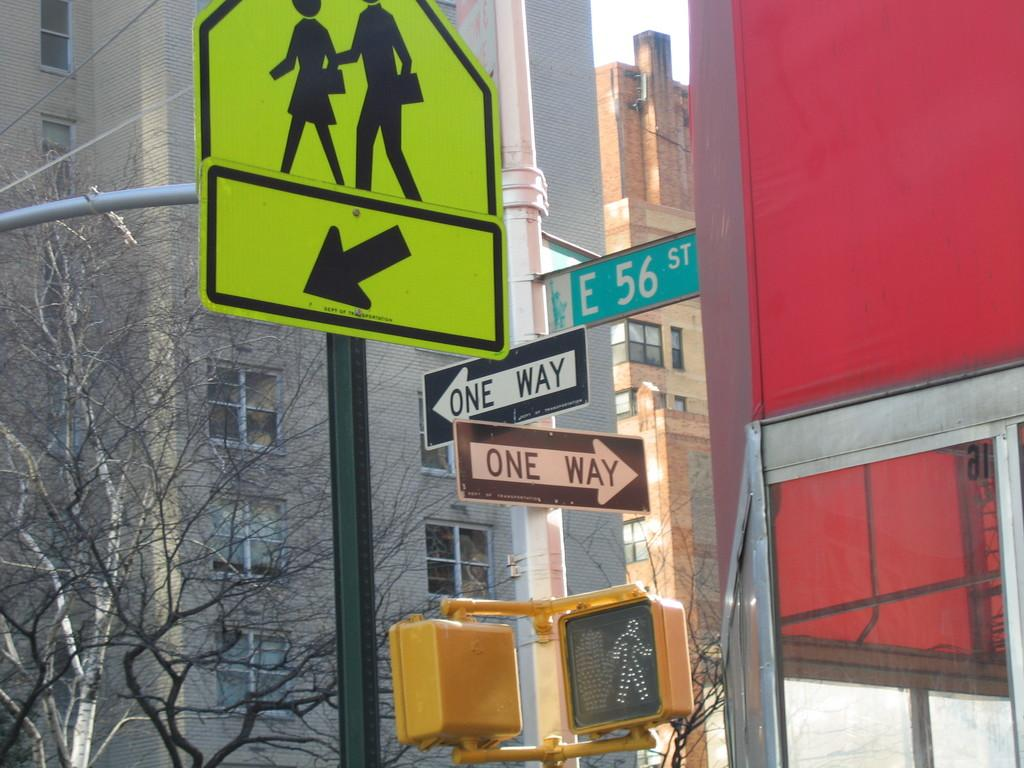<image>
Summarize the visual content of the image. The intersection at East 56 st has two one-way streets coming from it. 